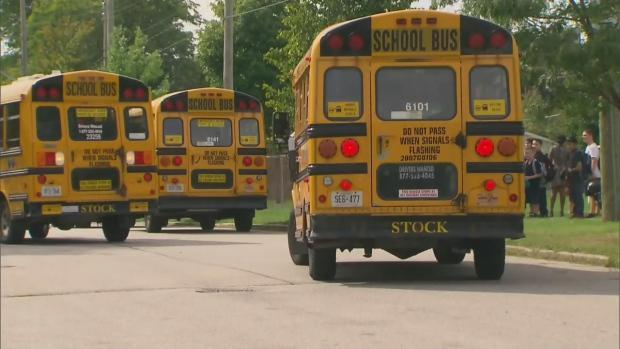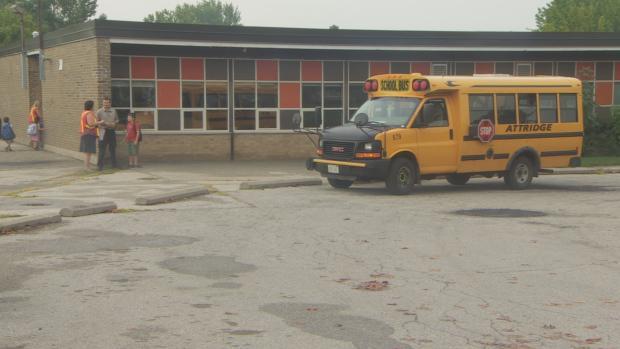The first image is the image on the left, the second image is the image on the right. For the images displayed, is the sentence "the left and right image contains the same number of buses." factually correct? Answer yes or no. No. The first image is the image on the left, the second image is the image on the right. For the images shown, is this caption "In the left image, a person is in the open doorway of a bus that faces rightward, with at least one foot on the first step." true? Answer yes or no. No. 